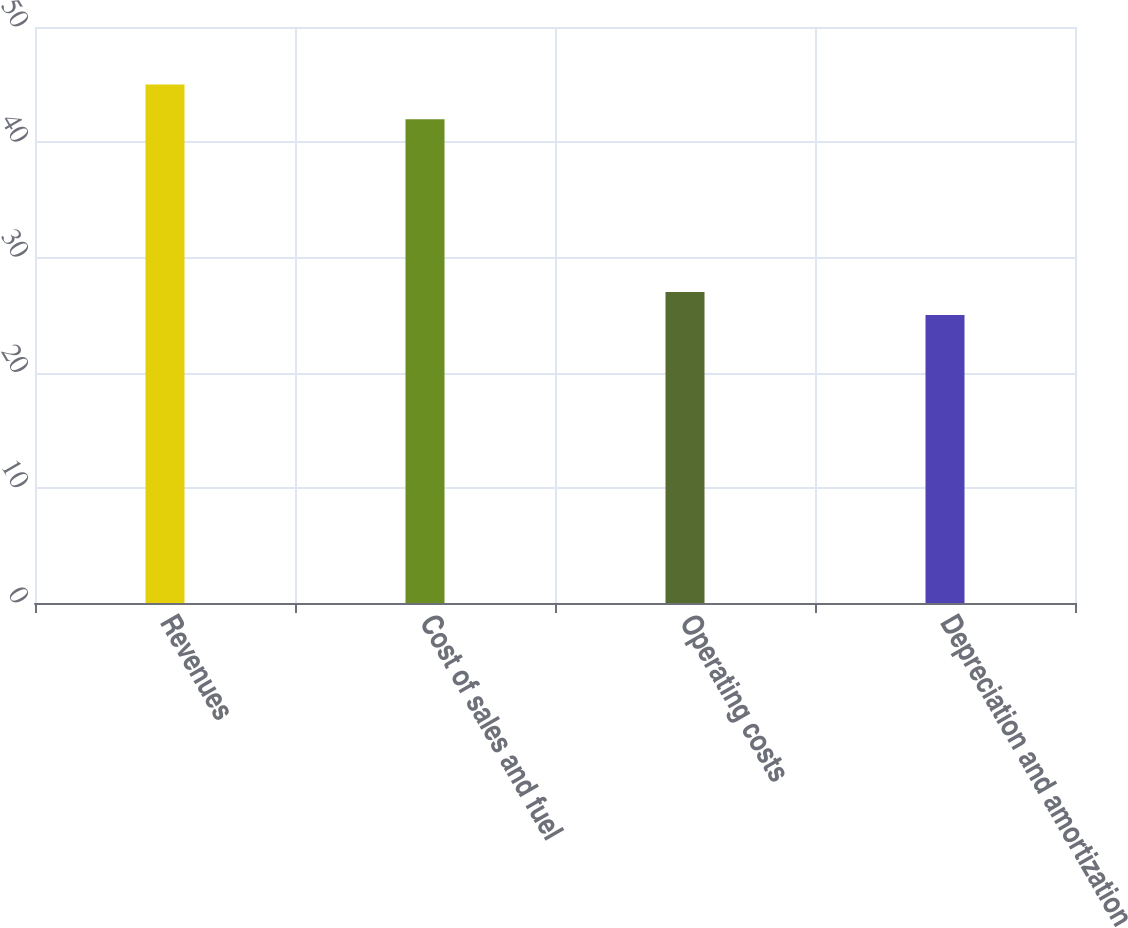<chart> <loc_0><loc_0><loc_500><loc_500><bar_chart><fcel>Revenues<fcel>Cost of sales and fuel<fcel>Operating costs<fcel>Depreciation and amortization<nl><fcel>45<fcel>42<fcel>27<fcel>25<nl></chart> 